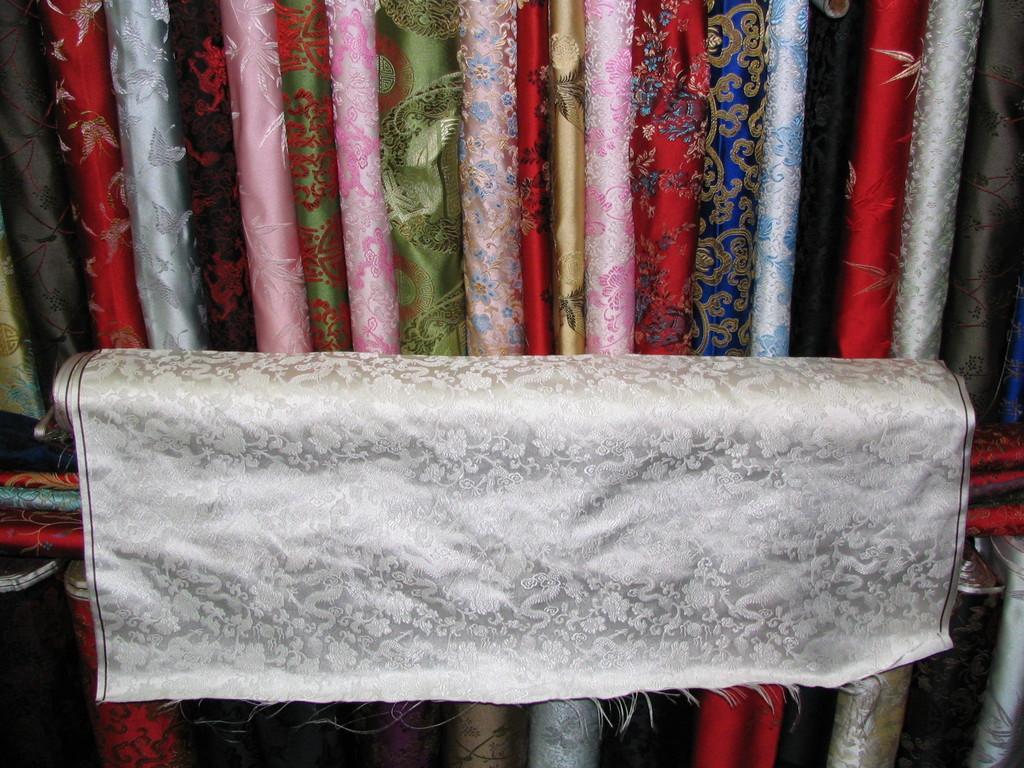Can you describe this image briefly? Here in this picture in the middle we can see a cloth roll present and behind that also we can see number of different types of cloth rolls present. 